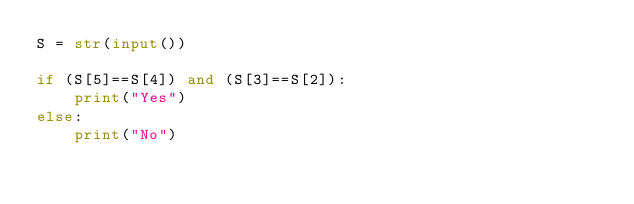<code> <loc_0><loc_0><loc_500><loc_500><_Python_>S = str(input())

if (S[5]==S[4]) and (S[3]==S[2]):
    print("Yes")
else:
    print("No")</code> 